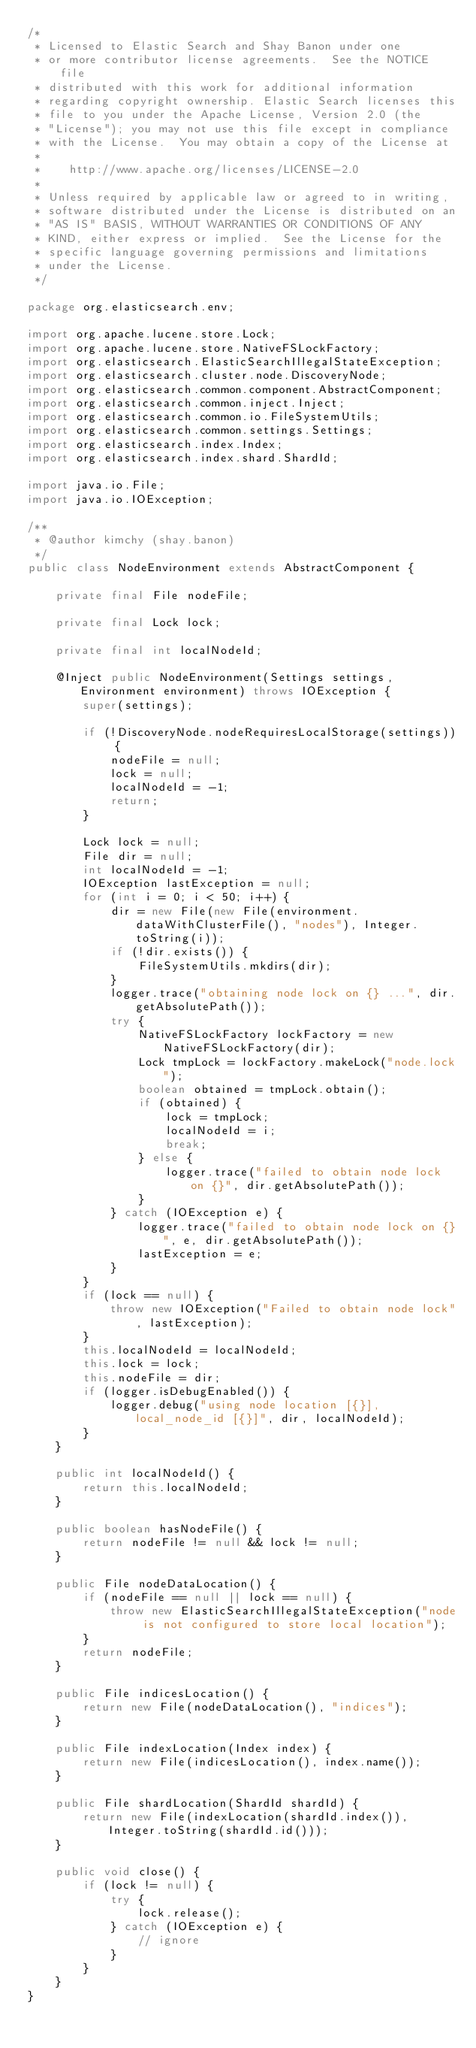Convert code to text. <code><loc_0><loc_0><loc_500><loc_500><_Java_>/*
 * Licensed to Elastic Search and Shay Banon under one
 * or more contributor license agreements.  See the NOTICE file
 * distributed with this work for additional information
 * regarding copyright ownership. Elastic Search licenses this
 * file to you under the Apache License, Version 2.0 (the
 * "License"); you may not use this file except in compliance
 * with the License.  You may obtain a copy of the License at
 *
 *    http://www.apache.org/licenses/LICENSE-2.0
 *
 * Unless required by applicable law or agreed to in writing,
 * software distributed under the License is distributed on an
 * "AS IS" BASIS, WITHOUT WARRANTIES OR CONDITIONS OF ANY
 * KIND, either express or implied.  See the License for the
 * specific language governing permissions and limitations
 * under the License.
 */

package org.elasticsearch.env;

import org.apache.lucene.store.Lock;
import org.apache.lucene.store.NativeFSLockFactory;
import org.elasticsearch.ElasticSearchIllegalStateException;
import org.elasticsearch.cluster.node.DiscoveryNode;
import org.elasticsearch.common.component.AbstractComponent;
import org.elasticsearch.common.inject.Inject;
import org.elasticsearch.common.io.FileSystemUtils;
import org.elasticsearch.common.settings.Settings;
import org.elasticsearch.index.Index;
import org.elasticsearch.index.shard.ShardId;

import java.io.File;
import java.io.IOException;

/**
 * @author kimchy (shay.banon)
 */
public class NodeEnvironment extends AbstractComponent {

    private final File nodeFile;

    private final Lock lock;

    private final int localNodeId;

    @Inject public NodeEnvironment(Settings settings, Environment environment) throws IOException {
        super(settings);

        if (!DiscoveryNode.nodeRequiresLocalStorage(settings)) {
            nodeFile = null;
            lock = null;
            localNodeId = -1;
            return;
        }

        Lock lock = null;
        File dir = null;
        int localNodeId = -1;
        IOException lastException = null;
        for (int i = 0; i < 50; i++) {
            dir = new File(new File(environment.dataWithClusterFile(), "nodes"), Integer.toString(i));
            if (!dir.exists()) {
                FileSystemUtils.mkdirs(dir);
            }
            logger.trace("obtaining node lock on {} ...", dir.getAbsolutePath());
            try {
                NativeFSLockFactory lockFactory = new NativeFSLockFactory(dir);
                Lock tmpLock = lockFactory.makeLock("node.lock");
                boolean obtained = tmpLock.obtain();
                if (obtained) {
                    lock = tmpLock;
                    localNodeId = i;
                    break;
                } else {
                    logger.trace("failed to obtain node lock on {}", dir.getAbsolutePath());
                }
            } catch (IOException e) {
                logger.trace("failed to obtain node lock on {}", e, dir.getAbsolutePath());
                lastException = e;
            }
        }
        if (lock == null) {
            throw new IOException("Failed to obtain node lock", lastException);
        }
        this.localNodeId = localNodeId;
        this.lock = lock;
        this.nodeFile = dir;
        if (logger.isDebugEnabled()) {
            logger.debug("using node location [{}], local_node_id [{}]", dir, localNodeId);
        }
    }

    public int localNodeId() {
        return this.localNodeId;
    }

    public boolean hasNodeFile() {
        return nodeFile != null && lock != null;
    }

    public File nodeDataLocation() {
        if (nodeFile == null || lock == null) {
            throw new ElasticSearchIllegalStateException("node is not configured to store local location");
        }
        return nodeFile;
    }

    public File indicesLocation() {
        return new File(nodeDataLocation(), "indices");
    }

    public File indexLocation(Index index) {
        return new File(indicesLocation(), index.name());
    }

    public File shardLocation(ShardId shardId) {
        return new File(indexLocation(shardId.index()), Integer.toString(shardId.id()));
    }

    public void close() {
        if (lock != null) {
            try {
                lock.release();
            } catch (IOException e) {
                // ignore
            }
        }
    }
}
</code> 